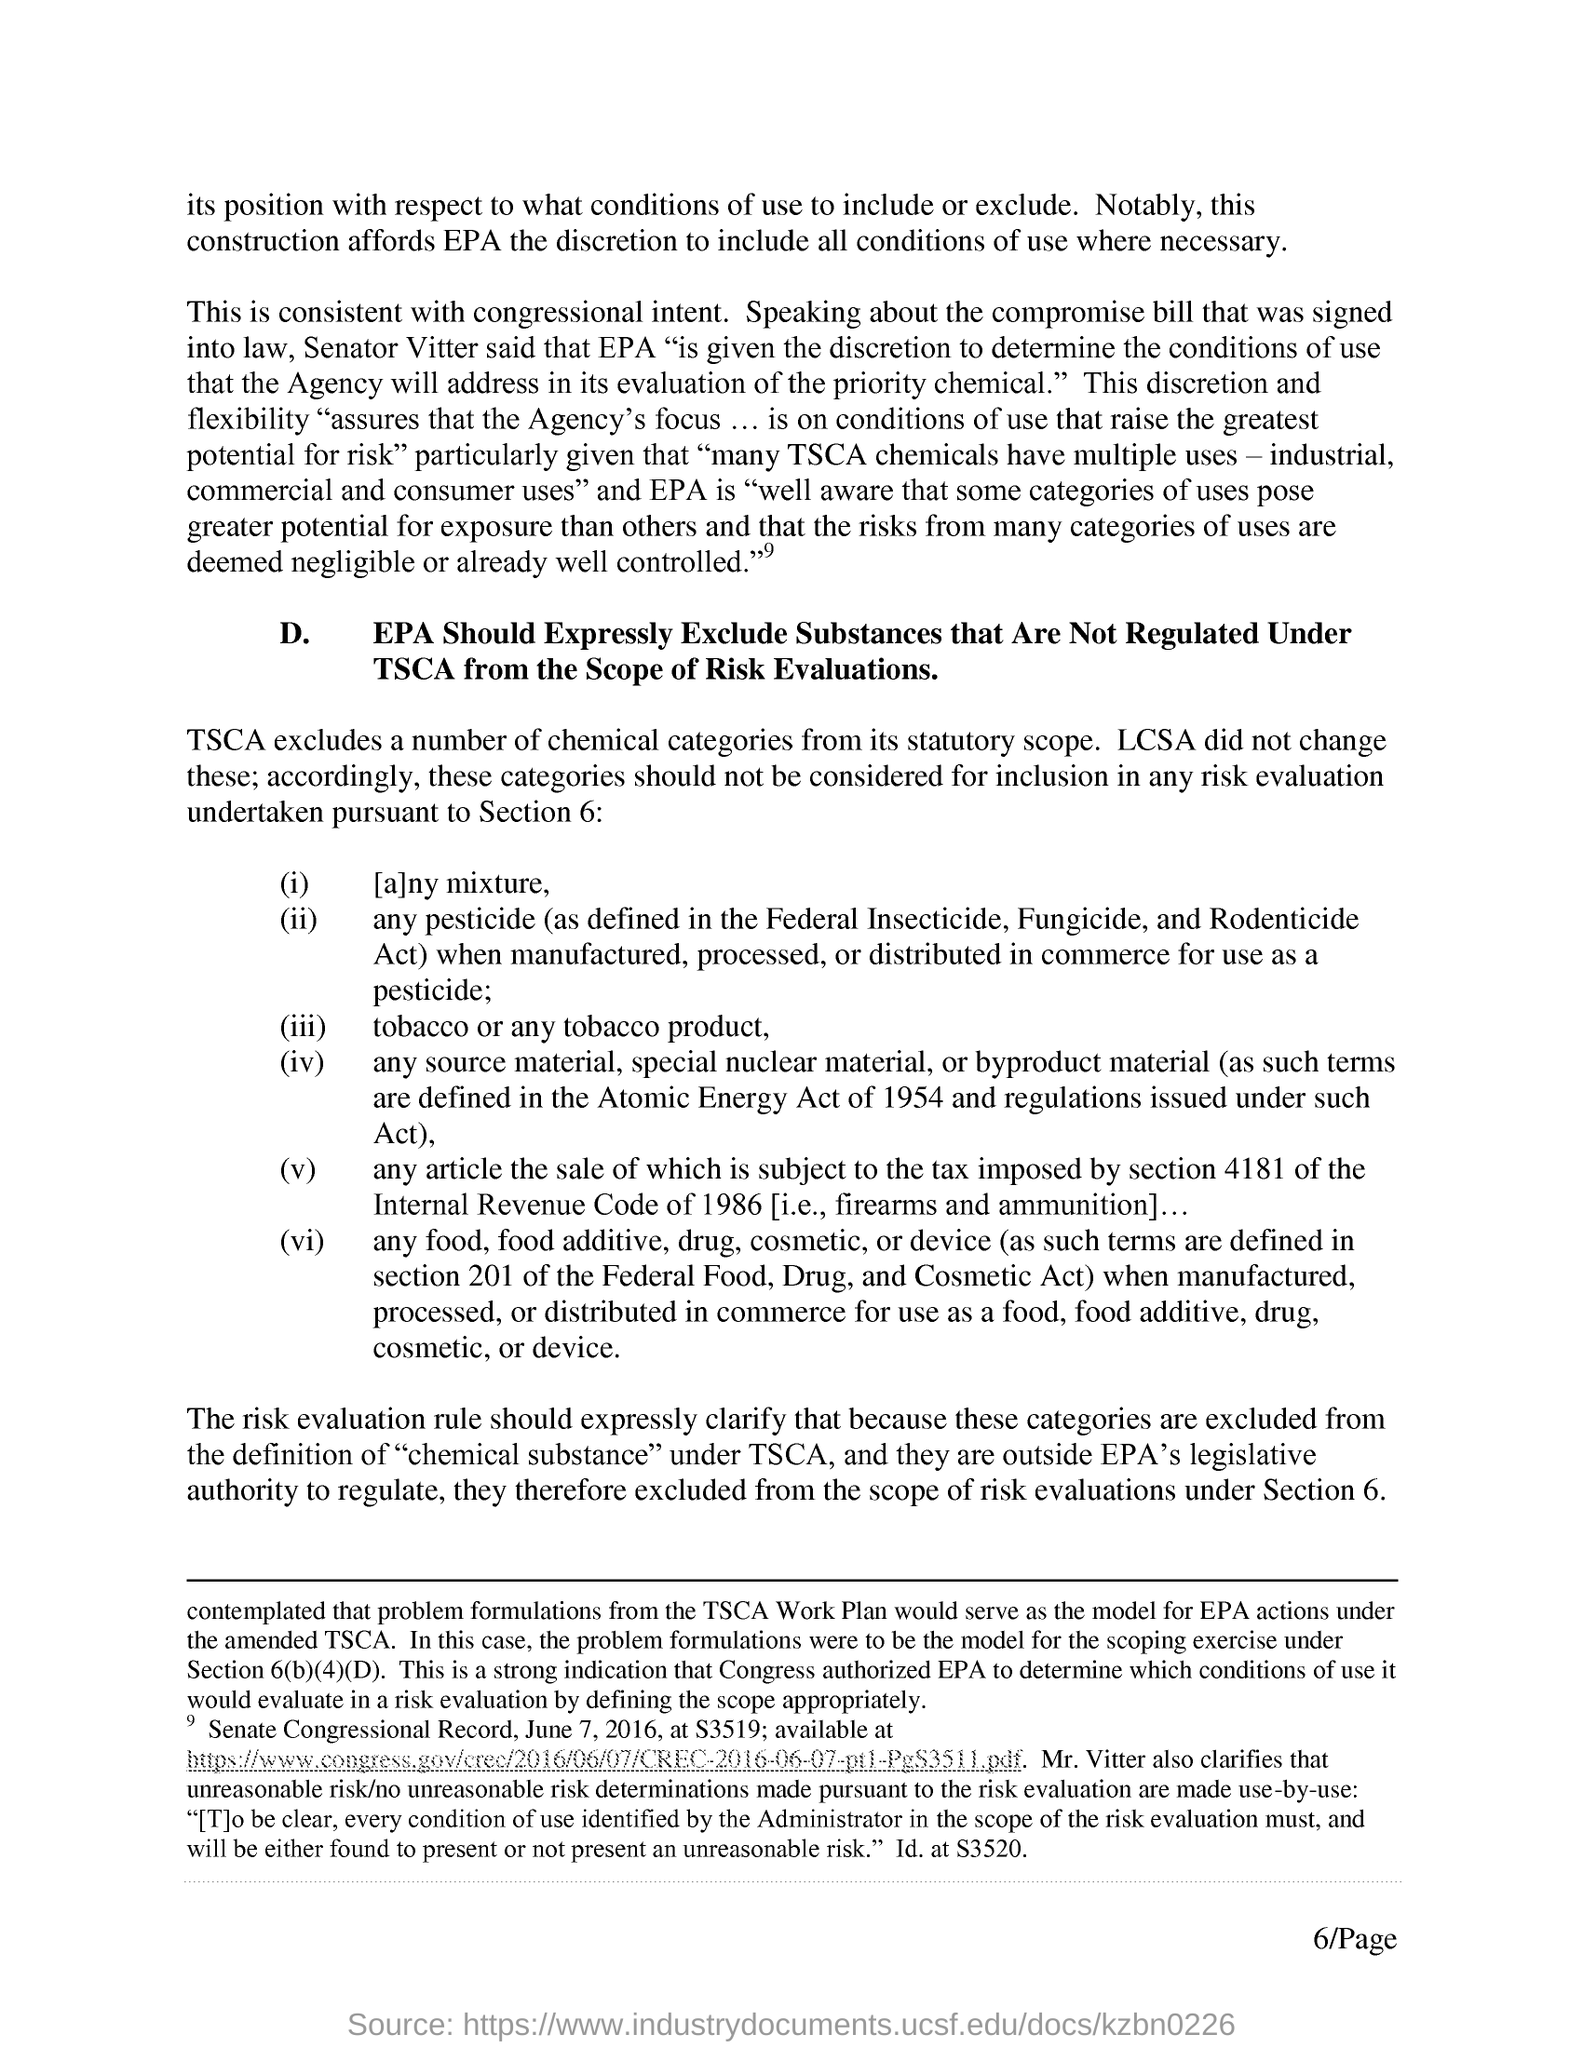Who said that epa"is given the discretion to determine the conditions of use that the agency will address in its evaluation of the priority chemical"
Provide a succinct answer. Senator vitter. In which year atomic energy act came into force?
Your answer should be very brief. 1954. Under which section the tax is imposed?
Provide a succinct answer. 4181. Which code is related to section 4181 tax is imposed?
Keep it short and to the point. Internal revenue code. Which excludes a number of chemical categories from its statutory scope?
Ensure brevity in your answer.  TSCA. 